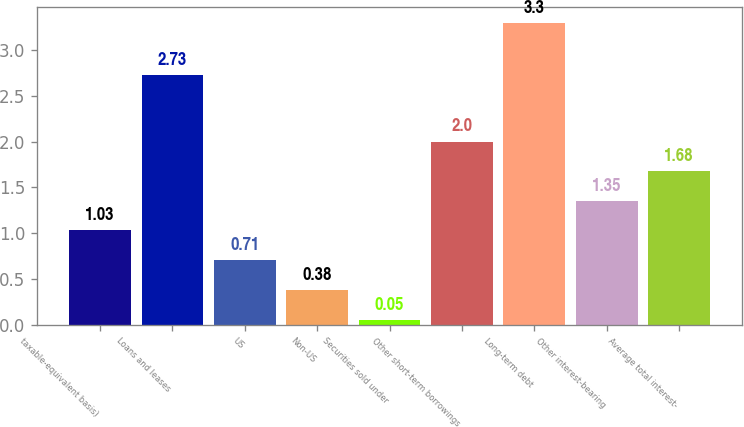Convert chart to OTSL. <chart><loc_0><loc_0><loc_500><loc_500><bar_chart><fcel>taxable-equivalent basis)<fcel>Loans and leases<fcel>US<fcel>Non-US<fcel>Securities sold under<fcel>Other short-term borrowings<fcel>Long-term debt<fcel>Other interest-bearing<fcel>Average total interest-<nl><fcel>1.03<fcel>2.73<fcel>0.71<fcel>0.38<fcel>0.05<fcel>2<fcel>3.3<fcel>1.35<fcel>1.68<nl></chart> 